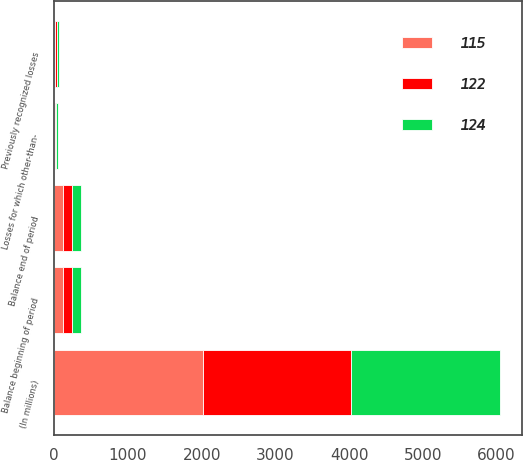<chart> <loc_0><loc_0><loc_500><loc_500><stacked_bar_chart><ecel><fcel>(In millions)<fcel>Balance beginning of period<fcel>Losses for which other-than-<fcel>Previously recognized losses<fcel>Balance end of period<nl><fcel>115<fcel>2014<fcel>122<fcel>11<fcel>12<fcel>115<nl><fcel>122<fcel>2013<fcel>124<fcel>9<fcel>25<fcel>122<nl><fcel>124<fcel>2012<fcel>113<fcel>28<fcel>21<fcel>124<nl></chart> 